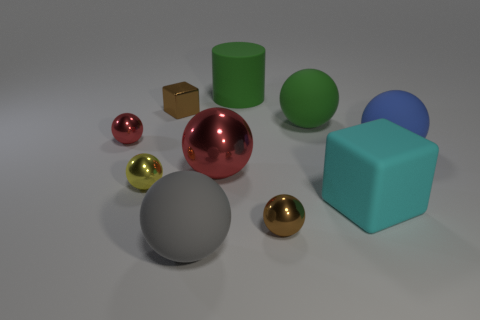Subtract all green balls. How many balls are left? 6 Subtract all tiny brown metal spheres. How many spheres are left? 6 Subtract all purple spheres. Subtract all cyan cylinders. How many spheres are left? 7 Subtract all cubes. How many objects are left? 8 Add 4 big green rubber objects. How many big green rubber objects exist? 6 Subtract 0 yellow cylinders. How many objects are left? 10 Subtract all big matte things. Subtract all large blue balls. How many objects are left? 4 Add 3 tiny brown metallic blocks. How many tiny brown metallic blocks are left? 4 